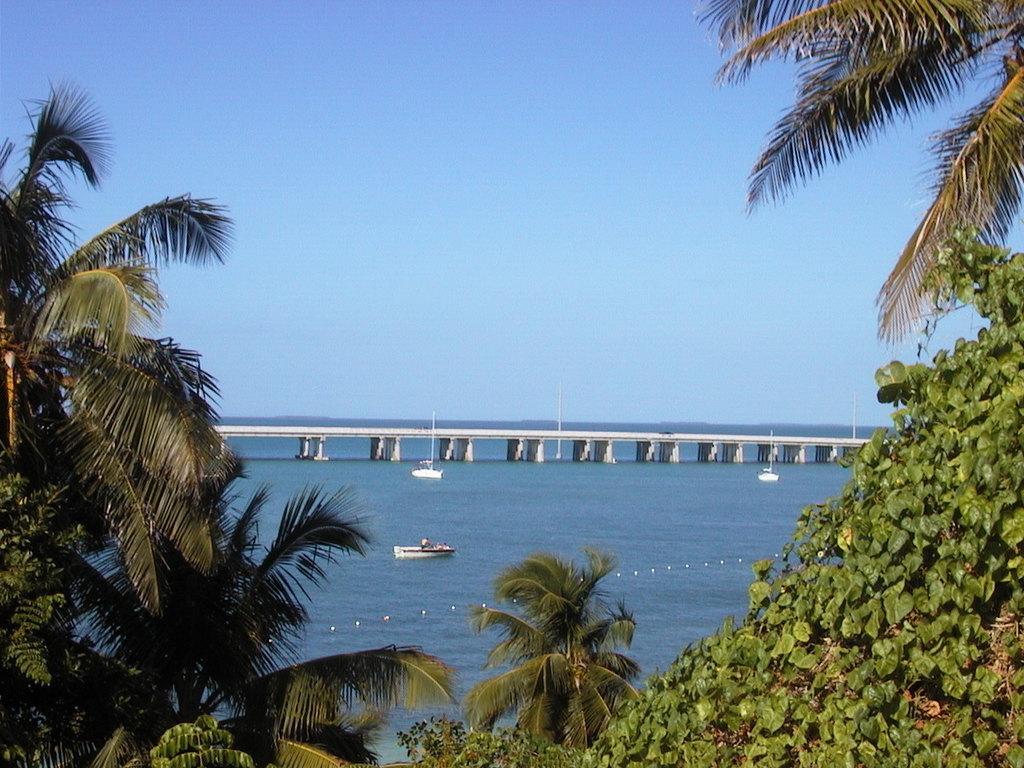Please provide a concise description of this image. There are trees at the bottom of this image. We can see boats and a bridge on the surface of water and the sky is in the background. 